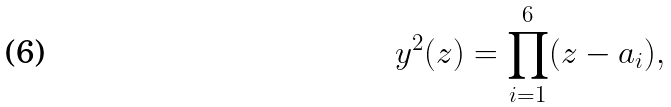<formula> <loc_0><loc_0><loc_500><loc_500>y ^ { 2 } ( z ) = \prod _ { i = 1 } ^ { 6 } ( z - a _ { i } ) ,</formula> 